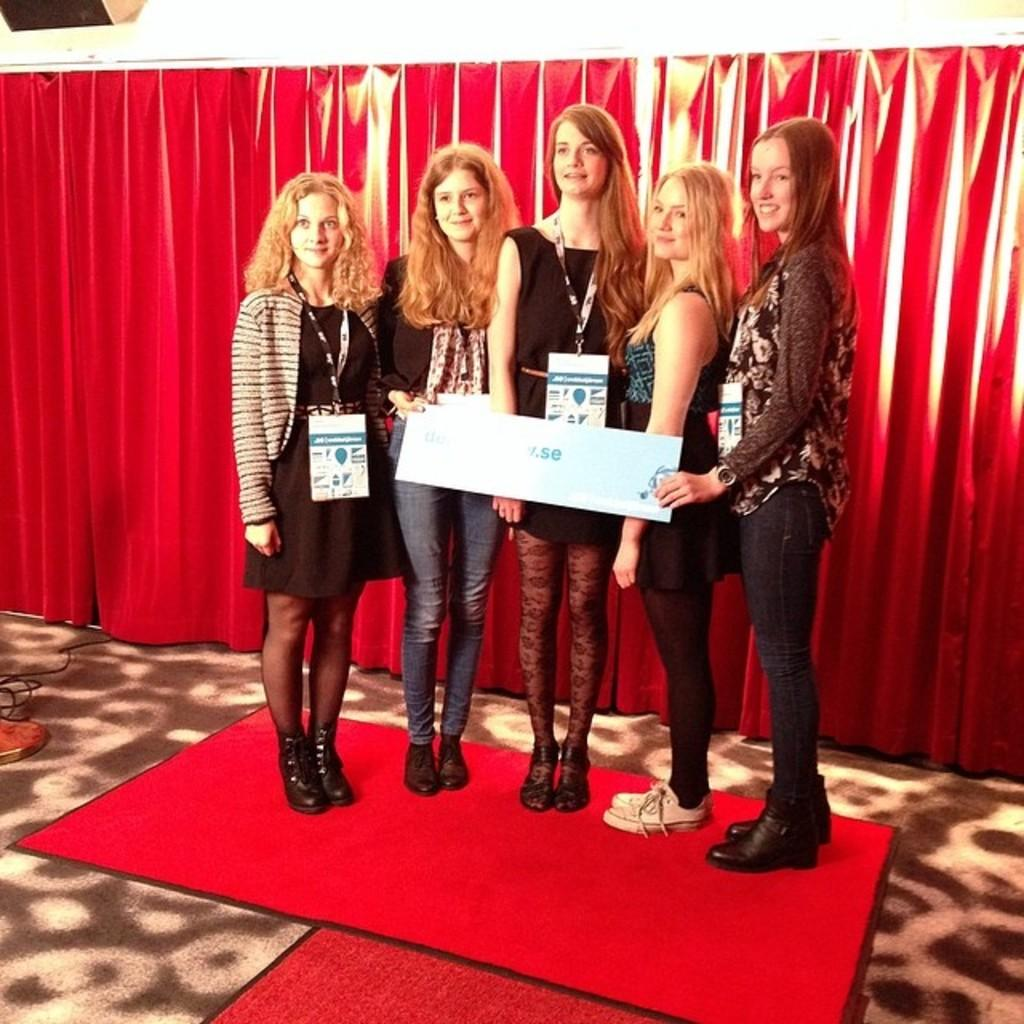How many women are present in the image? There are five women in the image. What are the women standing on? The women are standing on a red carpet. What expression do the women have? The women are smiling. What can be seen in the background of the image? There is a red curtain in the background of the image. What type of jelly is being taught by the women in the image? There is no jelly or teaching activity present in the image. What type of crib is visible in the image? There is no crib present in the image. 